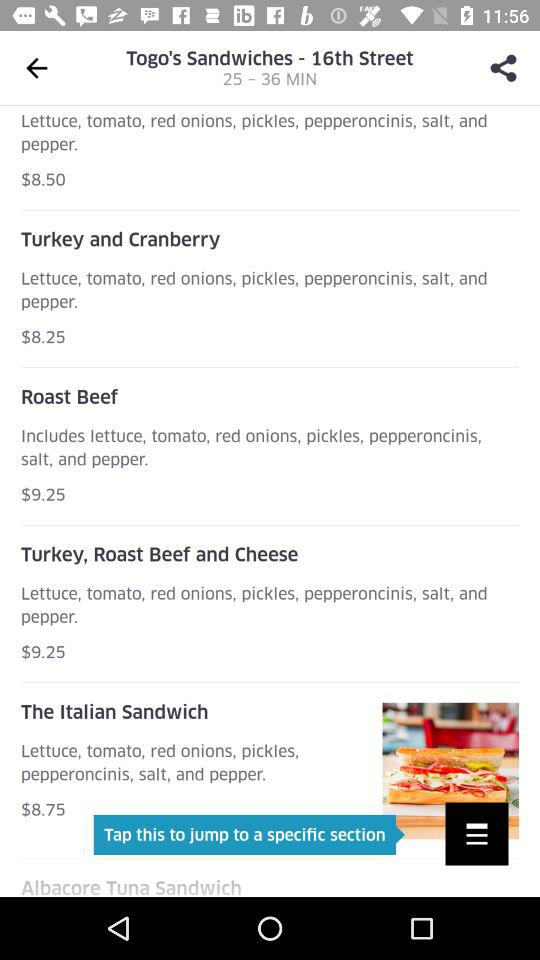What is the price of the "Roast Beef" recipe? The price is $9.25. 